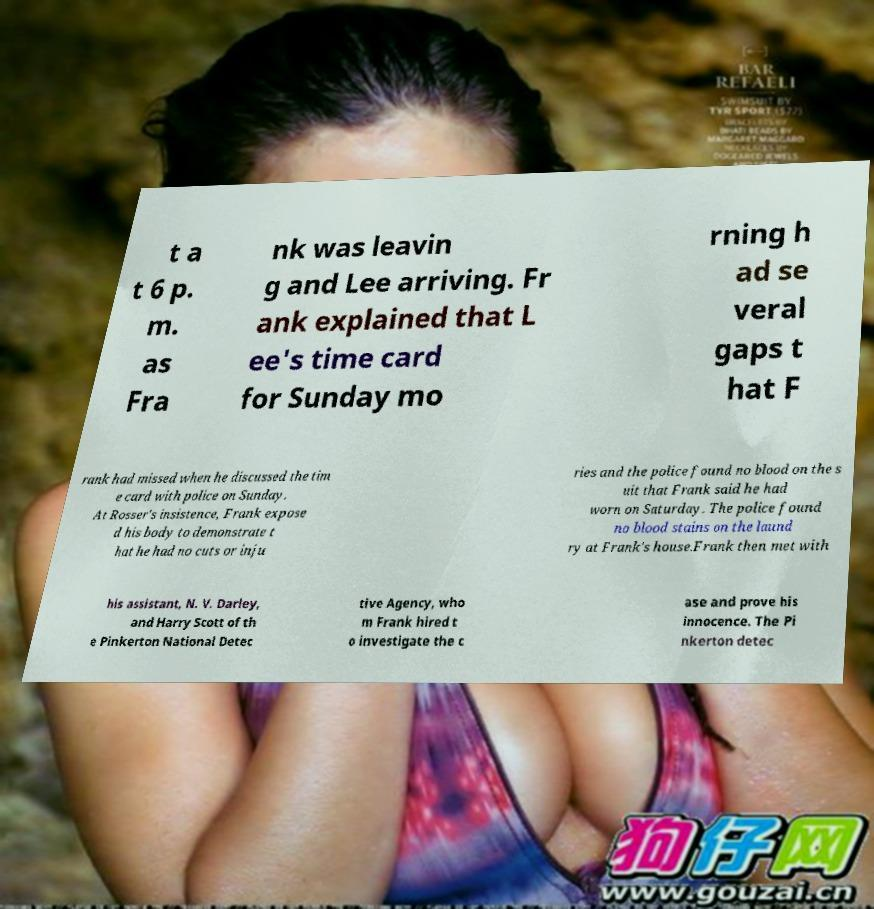Please identify and transcribe the text found in this image. t a t 6 p. m. as Fra nk was leavin g and Lee arriving. Fr ank explained that L ee's time card for Sunday mo rning h ad se veral gaps t hat F rank had missed when he discussed the tim e card with police on Sunday. At Rosser's insistence, Frank expose d his body to demonstrate t hat he had no cuts or inju ries and the police found no blood on the s uit that Frank said he had worn on Saturday. The police found no blood stains on the laund ry at Frank's house.Frank then met with his assistant, N. V. Darley, and Harry Scott of th e Pinkerton National Detec tive Agency, who m Frank hired t o investigate the c ase and prove his innocence. The Pi nkerton detec 